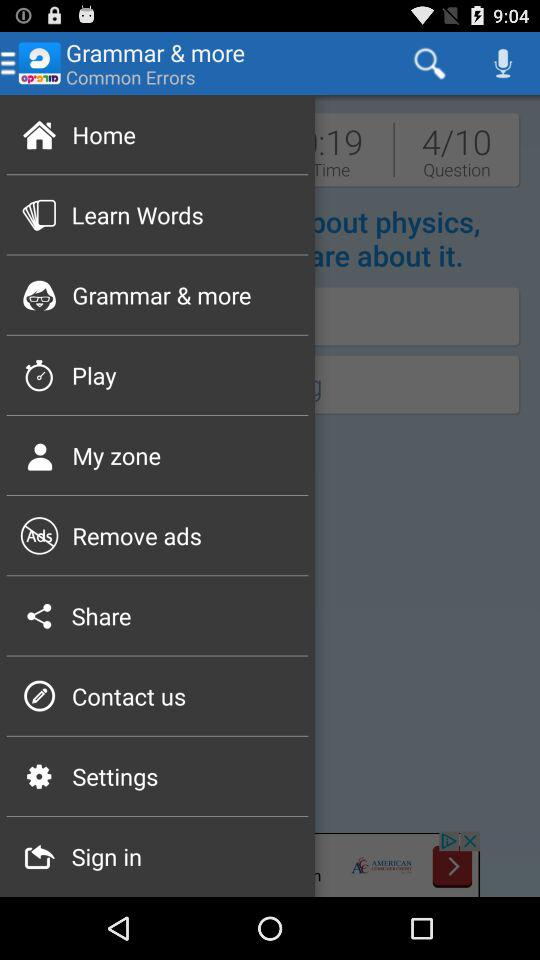How many questions have been covered out of the total? There have been 4 questions covered out of the total. 